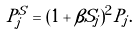Convert formula to latex. <formula><loc_0><loc_0><loc_500><loc_500>P ^ { S } _ { j } = ( 1 + \beta S _ { j } ) ^ { 2 } P _ { j } .</formula> 